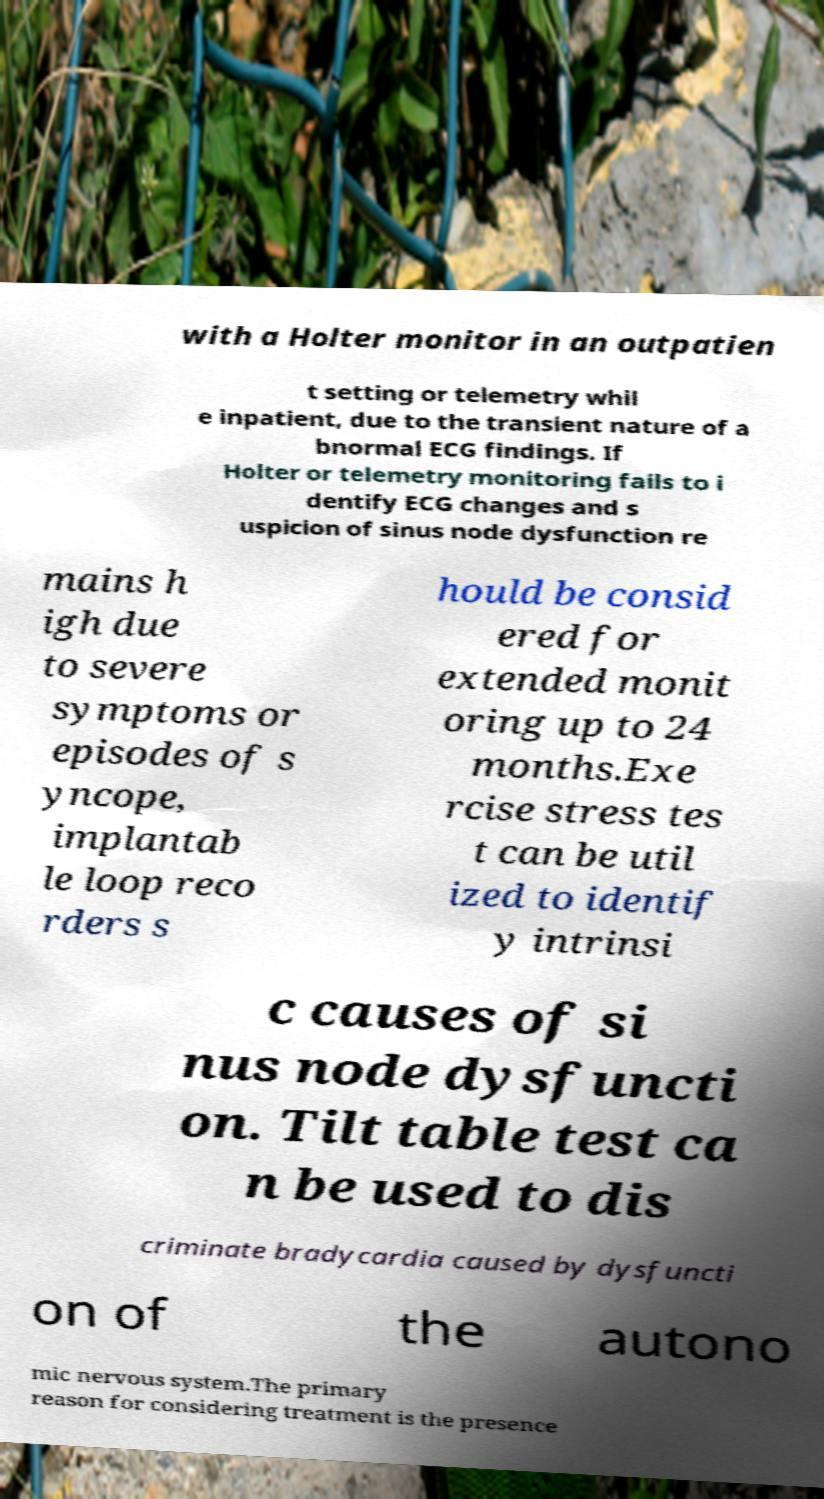For documentation purposes, I need the text within this image transcribed. Could you provide that? with a Holter monitor in an outpatien t setting or telemetry whil e inpatient, due to the transient nature of a bnormal ECG findings. If Holter or telemetry monitoring fails to i dentify ECG changes and s uspicion of sinus node dysfunction re mains h igh due to severe symptoms or episodes of s yncope, implantab le loop reco rders s hould be consid ered for extended monit oring up to 24 months.Exe rcise stress tes t can be util ized to identif y intrinsi c causes of si nus node dysfuncti on. Tilt table test ca n be used to dis criminate bradycardia caused by dysfuncti on of the autono mic nervous system.The primary reason for considering treatment is the presence 